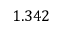<formula> <loc_0><loc_0><loc_500><loc_500>1 . 3 4 2</formula> 